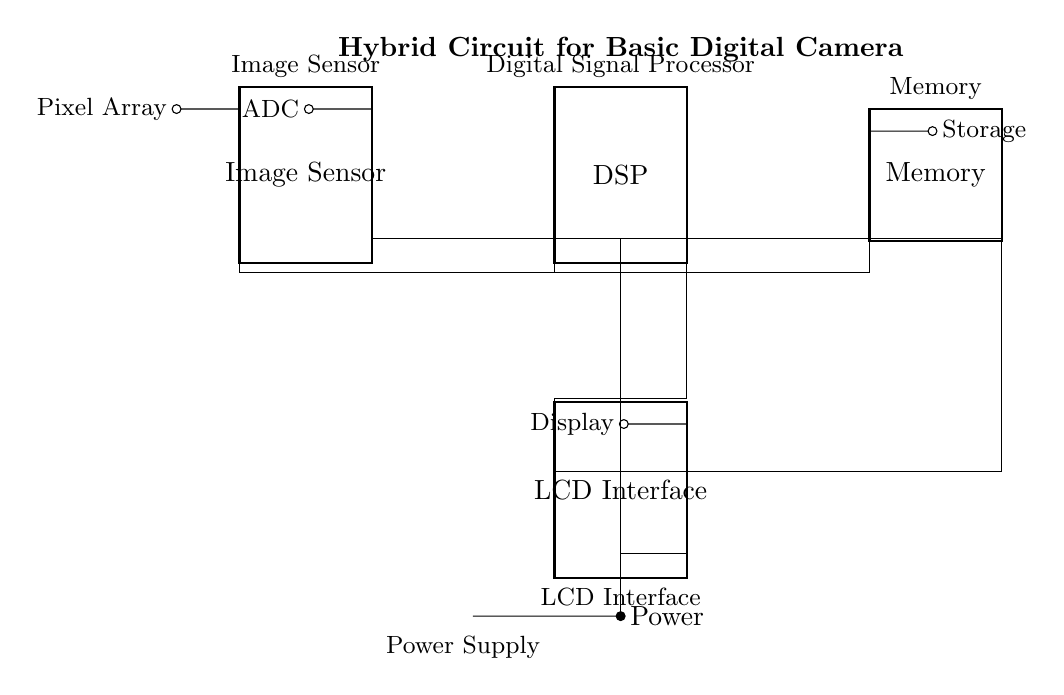What is the main component for capturing images? The main component responsible for capturing images in this circuit is the Image Sensor, which is depicted as a chip in the diagram.
Answer: Image Sensor How many pins are on the Digital Signal Processor? The Digital Signal Processor, as indicated in the circuit diagram, has 8 pins, which are essential for connecting to other components in the circuit.
Answer: 8 What is stored in the Memory component? The Memory component is primarily used for Storage, which is indicated by the label attached to its corresponding pin in the diagram.
Answer: Storage What component does the LCD Interface connect to? The LCD Interface is connected to the Display, as shown by the labeled connection leading out from the interface in the circuit diagram.
Answer: Display What is the function of the power supply? The Power Supply provides the necessary electrical power to the entire circuit, as evidenced by the connections stemming from the battery symbol in the diagram.
Answer: Power Which components are connected to the Memory? The Memory is connected to the Digital Signal Processor and the LCD Interface, which are indicated by the lines and pins connecting these components in the circuit diagram.
Answer: Digital Signal Processor, LCD Interface What role does the Image Sensor play in relation to the Digital Signal Processor? The Image Sensor captures images and sends the data to the Digital Signal Processor for processing, which is shown by the connection line going from the Image Sensor to the respective pin of the Digital Signal Processor.
Answer: Image capture and data processing 